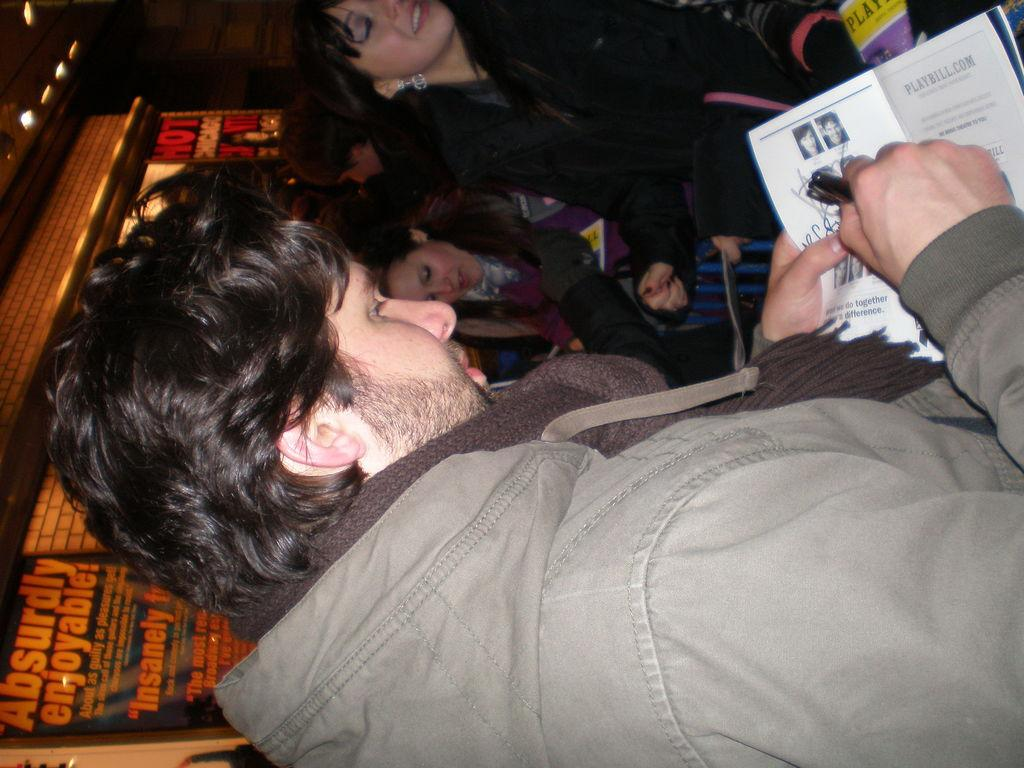What is the man in the image holding? The man is holding a book in the image. What else can be seen in the image besides the man? There are posters, people, lights, and objects in the image. Can you describe the posters in the image? Unfortunately, the facts provided do not give specific details about the posters. How many people are present in the image? The facts provided do not specify the exact number of people in the image. What type of power does the crow use to fly in the image? There is no crow present in the image, so it is not possible to determine the type of power it might use to fly. What day of the week is depicted in the image? The facts provided do not give any information about the day of the week, so it is not possible to determine which day is depicted in the image. 